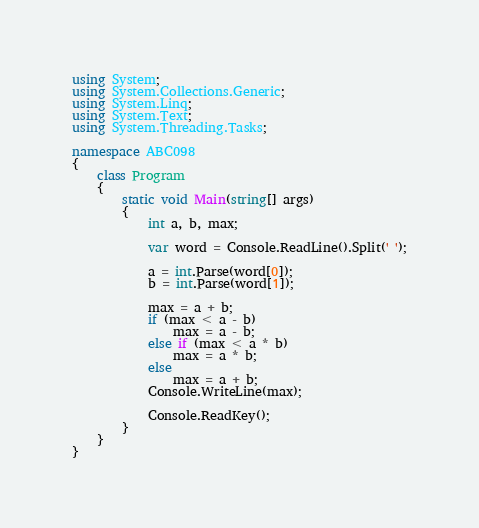Convert code to text. <code><loc_0><loc_0><loc_500><loc_500><_C#_>using System;
using System.Collections.Generic;
using System.Linq;
using System.Text;
using System.Threading.Tasks;

namespace ABC098
{
    class Program
    {
        static void Main(string[] args)
        {
            int a, b, max;

            var word = Console.ReadLine().Split(' ');

            a = int.Parse(word[0]);
            b = int.Parse(word[1]);

            max = a + b;
			if (max < a - b)
				max = a - b;
			else if (max < a * b)
				max = a * b;
			else
				max = a + b;
            Console.WriteLine(max);

            Console.ReadKey();
        }
    }
}
</code> 